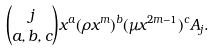<formula> <loc_0><loc_0><loc_500><loc_500>\binom { j } { a , b , c } x ^ { a } ( \rho x ^ { m } ) ^ { b } ( \mu x ^ { 2 m - 1 } ) ^ { c } A _ { j } .</formula> 